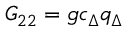<formula> <loc_0><loc_0><loc_500><loc_500>G _ { 2 2 } = g c _ { \Delta } q _ { \Delta }</formula> 